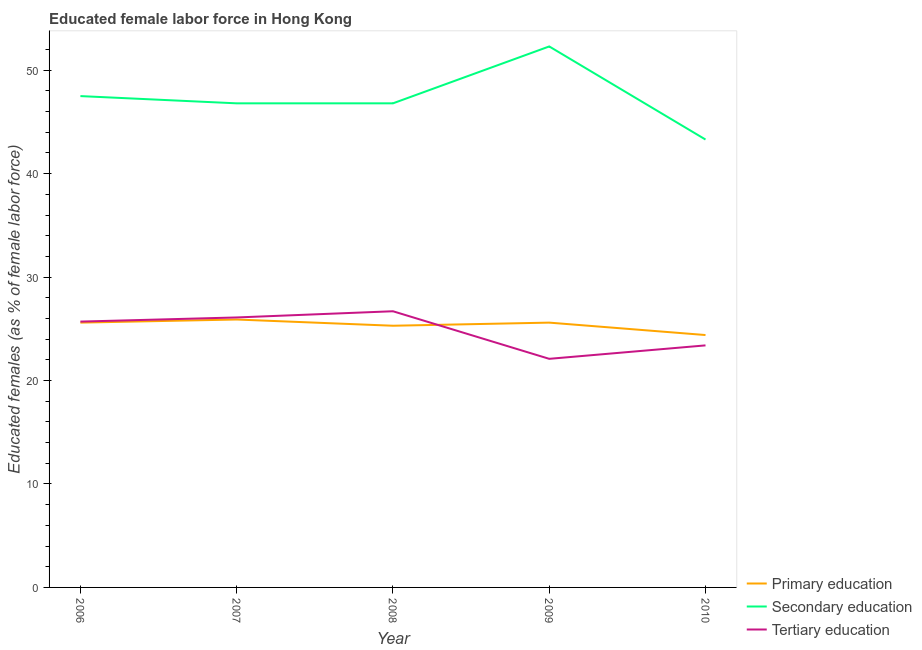How many different coloured lines are there?
Your answer should be compact. 3. What is the percentage of female labor force who received tertiary education in 2007?
Offer a very short reply. 26.1. Across all years, what is the maximum percentage of female labor force who received secondary education?
Your answer should be compact. 52.3. Across all years, what is the minimum percentage of female labor force who received tertiary education?
Offer a terse response. 22.1. In which year was the percentage of female labor force who received primary education minimum?
Offer a terse response. 2010. What is the total percentage of female labor force who received primary education in the graph?
Provide a short and direct response. 126.8. What is the difference between the percentage of female labor force who received primary education in 2010 and the percentage of female labor force who received secondary education in 2006?
Ensure brevity in your answer.  -23.1. What is the average percentage of female labor force who received secondary education per year?
Ensure brevity in your answer.  47.34. In the year 2010, what is the difference between the percentage of female labor force who received primary education and percentage of female labor force who received tertiary education?
Provide a succinct answer. 1. Is the percentage of female labor force who received secondary education in 2007 less than that in 2009?
Offer a terse response. Yes. Is the difference between the percentage of female labor force who received primary education in 2006 and 2007 greater than the difference between the percentage of female labor force who received tertiary education in 2006 and 2007?
Offer a terse response. Yes. What is the difference between the highest and the second highest percentage of female labor force who received tertiary education?
Make the answer very short. 0.6. What is the difference between the highest and the lowest percentage of female labor force who received secondary education?
Make the answer very short. 9. Is the sum of the percentage of female labor force who received primary education in 2009 and 2010 greater than the maximum percentage of female labor force who received tertiary education across all years?
Your answer should be very brief. Yes. Is it the case that in every year, the sum of the percentage of female labor force who received primary education and percentage of female labor force who received secondary education is greater than the percentage of female labor force who received tertiary education?
Your answer should be compact. Yes. Is the percentage of female labor force who received tertiary education strictly greater than the percentage of female labor force who received secondary education over the years?
Provide a short and direct response. No. Is the percentage of female labor force who received secondary education strictly less than the percentage of female labor force who received primary education over the years?
Your answer should be very brief. No. What is the difference between two consecutive major ticks on the Y-axis?
Give a very brief answer. 10. Does the graph contain any zero values?
Keep it short and to the point. No. Does the graph contain grids?
Give a very brief answer. No. How many legend labels are there?
Make the answer very short. 3. How are the legend labels stacked?
Your answer should be compact. Vertical. What is the title of the graph?
Your answer should be very brief. Educated female labor force in Hong Kong. What is the label or title of the Y-axis?
Offer a terse response. Educated females (as % of female labor force). What is the Educated females (as % of female labor force) in Primary education in 2006?
Provide a short and direct response. 25.6. What is the Educated females (as % of female labor force) in Secondary education in 2006?
Give a very brief answer. 47.5. What is the Educated females (as % of female labor force) in Tertiary education in 2006?
Ensure brevity in your answer.  25.7. What is the Educated females (as % of female labor force) of Primary education in 2007?
Offer a very short reply. 25.9. What is the Educated females (as % of female labor force) in Secondary education in 2007?
Provide a succinct answer. 46.8. What is the Educated females (as % of female labor force) in Tertiary education in 2007?
Your answer should be very brief. 26.1. What is the Educated females (as % of female labor force) in Primary education in 2008?
Your response must be concise. 25.3. What is the Educated females (as % of female labor force) in Secondary education in 2008?
Provide a succinct answer. 46.8. What is the Educated females (as % of female labor force) in Tertiary education in 2008?
Your answer should be very brief. 26.7. What is the Educated females (as % of female labor force) of Primary education in 2009?
Ensure brevity in your answer.  25.6. What is the Educated females (as % of female labor force) in Secondary education in 2009?
Your response must be concise. 52.3. What is the Educated females (as % of female labor force) of Tertiary education in 2009?
Give a very brief answer. 22.1. What is the Educated females (as % of female labor force) of Primary education in 2010?
Offer a very short reply. 24.4. What is the Educated females (as % of female labor force) in Secondary education in 2010?
Provide a short and direct response. 43.3. What is the Educated females (as % of female labor force) of Tertiary education in 2010?
Keep it short and to the point. 23.4. Across all years, what is the maximum Educated females (as % of female labor force) of Primary education?
Offer a terse response. 25.9. Across all years, what is the maximum Educated females (as % of female labor force) in Secondary education?
Provide a succinct answer. 52.3. Across all years, what is the maximum Educated females (as % of female labor force) of Tertiary education?
Your answer should be compact. 26.7. Across all years, what is the minimum Educated females (as % of female labor force) of Primary education?
Offer a very short reply. 24.4. Across all years, what is the minimum Educated females (as % of female labor force) in Secondary education?
Your response must be concise. 43.3. Across all years, what is the minimum Educated females (as % of female labor force) in Tertiary education?
Your answer should be compact. 22.1. What is the total Educated females (as % of female labor force) of Primary education in the graph?
Provide a short and direct response. 126.8. What is the total Educated females (as % of female labor force) in Secondary education in the graph?
Offer a terse response. 236.7. What is the total Educated females (as % of female labor force) in Tertiary education in the graph?
Offer a very short reply. 124. What is the difference between the Educated females (as % of female labor force) of Primary education in 2006 and that in 2007?
Your response must be concise. -0.3. What is the difference between the Educated females (as % of female labor force) in Secondary education in 2006 and that in 2007?
Provide a short and direct response. 0.7. What is the difference between the Educated females (as % of female labor force) of Primary education in 2006 and that in 2009?
Make the answer very short. 0. What is the difference between the Educated females (as % of female labor force) of Secondary education in 2006 and that in 2009?
Give a very brief answer. -4.8. What is the difference between the Educated females (as % of female labor force) in Primary education in 2007 and that in 2008?
Offer a very short reply. 0.6. What is the difference between the Educated females (as % of female labor force) in Secondary education in 2007 and that in 2008?
Provide a short and direct response. 0. What is the difference between the Educated females (as % of female labor force) in Secondary education in 2007 and that in 2009?
Provide a succinct answer. -5.5. What is the difference between the Educated females (as % of female labor force) in Tertiary education in 2007 and that in 2009?
Your answer should be very brief. 4. What is the difference between the Educated females (as % of female labor force) in Primary education in 2007 and that in 2010?
Give a very brief answer. 1.5. What is the difference between the Educated females (as % of female labor force) in Tertiary education in 2007 and that in 2010?
Make the answer very short. 2.7. What is the difference between the Educated females (as % of female labor force) of Secondary education in 2008 and that in 2009?
Your answer should be compact. -5.5. What is the difference between the Educated females (as % of female labor force) of Tertiary education in 2008 and that in 2009?
Your answer should be very brief. 4.6. What is the difference between the Educated females (as % of female labor force) in Secondary education in 2009 and that in 2010?
Offer a terse response. 9. What is the difference between the Educated females (as % of female labor force) in Primary education in 2006 and the Educated females (as % of female labor force) in Secondary education in 2007?
Ensure brevity in your answer.  -21.2. What is the difference between the Educated females (as % of female labor force) in Primary education in 2006 and the Educated females (as % of female labor force) in Tertiary education in 2007?
Your answer should be very brief. -0.5. What is the difference between the Educated females (as % of female labor force) of Secondary education in 2006 and the Educated females (as % of female labor force) of Tertiary education in 2007?
Your answer should be compact. 21.4. What is the difference between the Educated females (as % of female labor force) in Primary education in 2006 and the Educated females (as % of female labor force) in Secondary education in 2008?
Provide a short and direct response. -21.2. What is the difference between the Educated females (as % of female labor force) in Secondary education in 2006 and the Educated females (as % of female labor force) in Tertiary education in 2008?
Keep it short and to the point. 20.8. What is the difference between the Educated females (as % of female labor force) in Primary education in 2006 and the Educated females (as % of female labor force) in Secondary education in 2009?
Offer a terse response. -26.7. What is the difference between the Educated females (as % of female labor force) in Primary education in 2006 and the Educated females (as % of female labor force) in Tertiary education in 2009?
Offer a terse response. 3.5. What is the difference between the Educated females (as % of female labor force) of Secondary education in 2006 and the Educated females (as % of female labor force) of Tertiary education in 2009?
Keep it short and to the point. 25.4. What is the difference between the Educated females (as % of female labor force) in Primary education in 2006 and the Educated females (as % of female labor force) in Secondary education in 2010?
Provide a succinct answer. -17.7. What is the difference between the Educated females (as % of female labor force) in Primary education in 2006 and the Educated females (as % of female labor force) in Tertiary education in 2010?
Make the answer very short. 2.2. What is the difference between the Educated females (as % of female labor force) in Secondary education in 2006 and the Educated females (as % of female labor force) in Tertiary education in 2010?
Your answer should be very brief. 24.1. What is the difference between the Educated females (as % of female labor force) of Primary education in 2007 and the Educated females (as % of female labor force) of Secondary education in 2008?
Your response must be concise. -20.9. What is the difference between the Educated females (as % of female labor force) of Primary education in 2007 and the Educated females (as % of female labor force) of Tertiary education in 2008?
Provide a short and direct response. -0.8. What is the difference between the Educated females (as % of female labor force) in Secondary education in 2007 and the Educated females (as % of female labor force) in Tertiary education in 2008?
Give a very brief answer. 20.1. What is the difference between the Educated females (as % of female labor force) in Primary education in 2007 and the Educated females (as % of female labor force) in Secondary education in 2009?
Ensure brevity in your answer.  -26.4. What is the difference between the Educated females (as % of female labor force) in Primary education in 2007 and the Educated females (as % of female labor force) in Tertiary education in 2009?
Make the answer very short. 3.8. What is the difference between the Educated females (as % of female labor force) in Secondary education in 2007 and the Educated females (as % of female labor force) in Tertiary education in 2009?
Give a very brief answer. 24.7. What is the difference between the Educated females (as % of female labor force) in Primary education in 2007 and the Educated females (as % of female labor force) in Secondary education in 2010?
Provide a short and direct response. -17.4. What is the difference between the Educated females (as % of female labor force) of Secondary education in 2007 and the Educated females (as % of female labor force) of Tertiary education in 2010?
Offer a terse response. 23.4. What is the difference between the Educated females (as % of female labor force) of Secondary education in 2008 and the Educated females (as % of female labor force) of Tertiary education in 2009?
Offer a very short reply. 24.7. What is the difference between the Educated females (as % of female labor force) in Primary education in 2008 and the Educated females (as % of female labor force) in Tertiary education in 2010?
Provide a short and direct response. 1.9. What is the difference between the Educated females (as % of female labor force) in Secondary education in 2008 and the Educated females (as % of female labor force) in Tertiary education in 2010?
Offer a terse response. 23.4. What is the difference between the Educated females (as % of female labor force) in Primary education in 2009 and the Educated females (as % of female labor force) in Secondary education in 2010?
Provide a short and direct response. -17.7. What is the difference between the Educated females (as % of female labor force) in Secondary education in 2009 and the Educated females (as % of female labor force) in Tertiary education in 2010?
Your response must be concise. 28.9. What is the average Educated females (as % of female labor force) in Primary education per year?
Ensure brevity in your answer.  25.36. What is the average Educated females (as % of female labor force) in Secondary education per year?
Provide a succinct answer. 47.34. What is the average Educated females (as % of female labor force) in Tertiary education per year?
Your answer should be compact. 24.8. In the year 2006, what is the difference between the Educated females (as % of female labor force) of Primary education and Educated females (as % of female labor force) of Secondary education?
Your answer should be very brief. -21.9. In the year 2006, what is the difference between the Educated females (as % of female labor force) in Primary education and Educated females (as % of female labor force) in Tertiary education?
Give a very brief answer. -0.1. In the year 2006, what is the difference between the Educated females (as % of female labor force) in Secondary education and Educated females (as % of female labor force) in Tertiary education?
Offer a very short reply. 21.8. In the year 2007, what is the difference between the Educated females (as % of female labor force) of Primary education and Educated females (as % of female labor force) of Secondary education?
Keep it short and to the point. -20.9. In the year 2007, what is the difference between the Educated females (as % of female labor force) of Primary education and Educated females (as % of female labor force) of Tertiary education?
Keep it short and to the point. -0.2. In the year 2007, what is the difference between the Educated females (as % of female labor force) of Secondary education and Educated females (as % of female labor force) of Tertiary education?
Your answer should be very brief. 20.7. In the year 2008, what is the difference between the Educated females (as % of female labor force) in Primary education and Educated females (as % of female labor force) in Secondary education?
Your answer should be compact. -21.5. In the year 2008, what is the difference between the Educated females (as % of female labor force) in Primary education and Educated females (as % of female labor force) in Tertiary education?
Offer a very short reply. -1.4. In the year 2008, what is the difference between the Educated females (as % of female labor force) in Secondary education and Educated females (as % of female labor force) in Tertiary education?
Keep it short and to the point. 20.1. In the year 2009, what is the difference between the Educated females (as % of female labor force) in Primary education and Educated females (as % of female labor force) in Secondary education?
Offer a terse response. -26.7. In the year 2009, what is the difference between the Educated females (as % of female labor force) in Primary education and Educated females (as % of female labor force) in Tertiary education?
Your answer should be very brief. 3.5. In the year 2009, what is the difference between the Educated females (as % of female labor force) of Secondary education and Educated females (as % of female labor force) of Tertiary education?
Give a very brief answer. 30.2. In the year 2010, what is the difference between the Educated females (as % of female labor force) of Primary education and Educated females (as % of female labor force) of Secondary education?
Give a very brief answer. -18.9. In the year 2010, what is the difference between the Educated females (as % of female labor force) in Primary education and Educated females (as % of female labor force) in Tertiary education?
Your answer should be compact. 1. What is the ratio of the Educated females (as % of female labor force) of Primary education in 2006 to that in 2007?
Your answer should be very brief. 0.99. What is the ratio of the Educated females (as % of female labor force) of Tertiary education in 2006 to that in 2007?
Provide a short and direct response. 0.98. What is the ratio of the Educated females (as % of female labor force) in Primary education in 2006 to that in 2008?
Make the answer very short. 1.01. What is the ratio of the Educated females (as % of female labor force) in Secondary education in 2006 to that in 2008?
Make the answer very short. 1.01. What is the ratio of the Educated females (as % of female labor force) in Tertiary education in 2006 to that in 2008?
Your response must be concise. 0.96. What is the ratio of the Educated females (as % of female labor force) of Primary education in 2006 to that in 2009?
Offer a very short reply. 1. What is the ratio of the Educated females (as % of female labor force) in Secondary education in 2006 to that in 2009?
Give a very brief answer. 0.91. What is the ratio of the Educated females (as % of female labor force) in Tertiary education in 2006 to that in 2009?
Keep it short and to the point. 1.16. What is the ratio of the Educated females (as % of female labor force) of Primary education in 2006 to that in 2010?
Offer a very short reply. 1.05. What is the ratio of the Educated females (as % of female labor force) in Secondary education in 2006 to that in 2010?
Your response must be concise. 1.1. What is the ratio of the Educated females (as % of female labor force) in Tertiary education in 2006 to that in 2010?
Provide a short and direct response. 1.1. What is the ratio of the Educated females (as % of female labor force) of Primary education in 2007 to that in 2008?
Offer a very short reply. 1.02. What is the ratio of the Educated females (as % of female labor force) in Secondary education in 2007 to that in 2008?
Your response must be concise. 1. What is the ratio of the Educated females (as % of female labor force) of Tertiary education in 2007 to that in 2008?
Make the answer very short. 0.98. What is the ratio of the Educated females (as % of female labor force) in Primary education in 2007 to that in 2009?
Your response must be concise. 1.01. What is the ratio of the Educated females (as % of female labor force) of Secondary education in 2007 to that in 2009?
Provide a short and direct response. 0.89. What is the ratio of the Educated females (as % of female labor force) of Tertiary education in 2007 to that in 2009?
Ensure brevity in your answer.  1.18. What is the ratio of the Educated females (as % of female labor force) in Primary education in 2007 to that in 2010?
Provide a short and direct response. 1.06. What is the ratio of the Educated females (as % of female labor force) of Secondary education in 2007 to that in 2010?
Provide a short and direct response. 1.08. What is the ratio of the Educated females (as % of female labor force) in Tertiary education in 2007 to that in 2010?
Provide a short and direct response. 1.12. What is the ratio of the Educated females (as % of female labor force) of Primary education in 2008 to that in 2009?
Keep it short and to the point. 0.99. What is the ratio of the Educated females (as % of female labor force) of Secondary education in 2008 to that in 2009?
Provide a short and direct response. 0.89. What is the ratio of the Educated females (as % of female labor force) in Tertiary education in 2008 to that in 2009?
Give a very brief answer. 1.21. What is the ratio of the Educated females (as % of female labor force) in Primary education in 2008 to that in 2010?
Provide a succinct answer. 1.04. What is the ratio of the Educated females (as % of female labor force) of Secondary education in 2008 to that in 2010?
Your answer should be very brief. 1.08. What is the ratio of the Educated females (as % of female labor force) of Tertiary education in 2008 to that in 2010?
Your response must be concise. 1.14. What is the ratio of the Educated females (as % of female labor force) in Primary education in 2009 to that in 2010?
Your answer should be compact. 1.05. What is the ratio of the Educated females (as % of female labor force) in Secondary education in 2009 to that in 2010?
Your answer should be very brief. 1.21. What is the ratio of the Educated females (as % of female labor force) of Tertiary education in 2009 to that in 2010?
Keep it short and to the point. 0.94. What is the difference between the highest and the second highest Educated females (as % of female labor force) of Tertiary education?
Keep it short and to the point. 0.6. What is the difference between the highest and the lowest Educated females (as % of female labor force) in Secondary education?
Make the answer very short. 9. What is the difference between the highest and the lowest Educated females (as % of female labor force) of Tertiary education?
Your response must be concise. 4.6. 